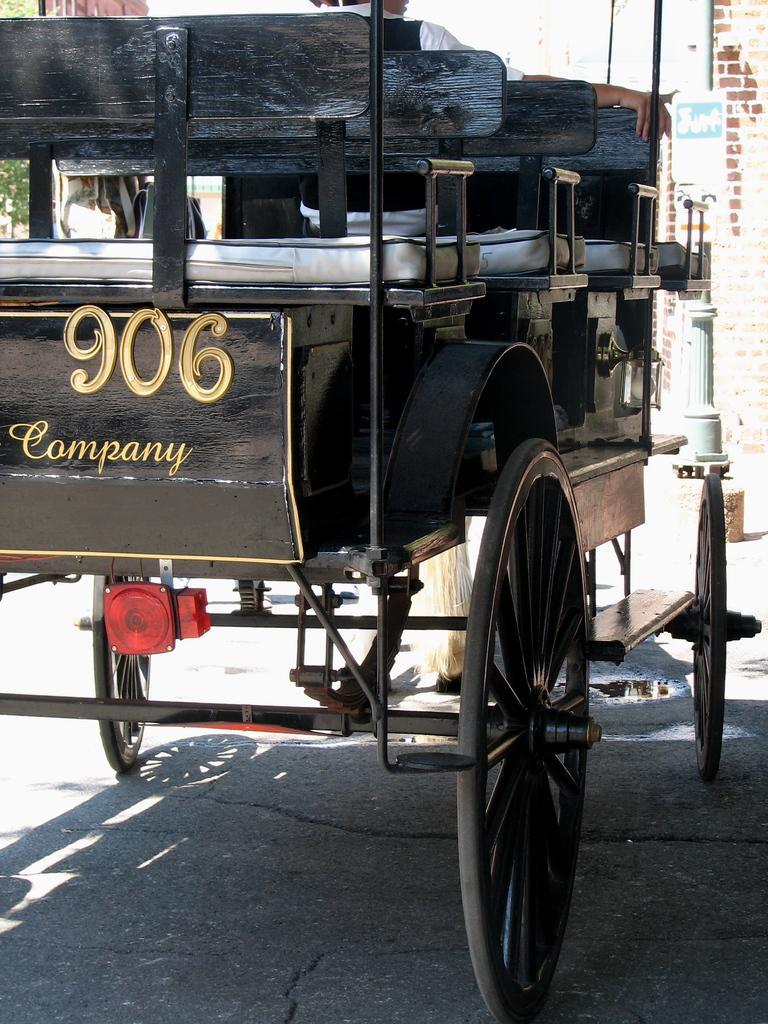Please provide a concise description of this image. In this image, we can see a cart with a person and some text. We can also see the ground. We can see a pole with some poster. We can see also see the wall. 